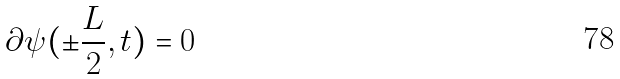Convert formula to latex. <formula><loc_0><loc_0><loc_500><loc_500>\partial \psi ( \pm \frac { L } { 2 } , t ) = 0</formula> 